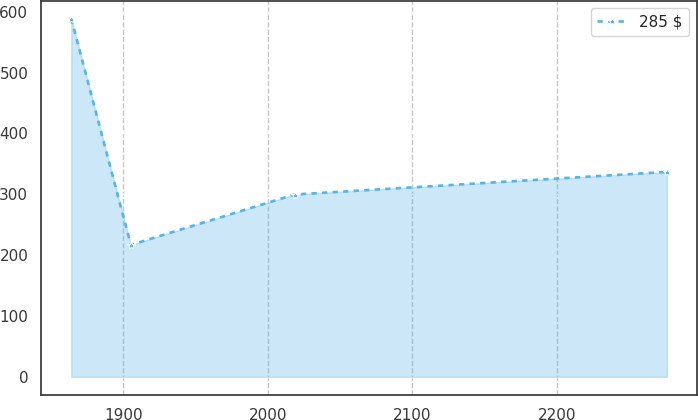Convert chart. <chart><loc_0><loc_0><loc_500><loc_500><line_chart><ecel><fcel>285 $<nl><fcel>1864.04<fcel>588.5<nl><fcel>1905.24<fcel>216.72<nl><fcel>2018.48<fcel>299.55<nl><fcel>2276<fcel>336.73<nl></chart> 